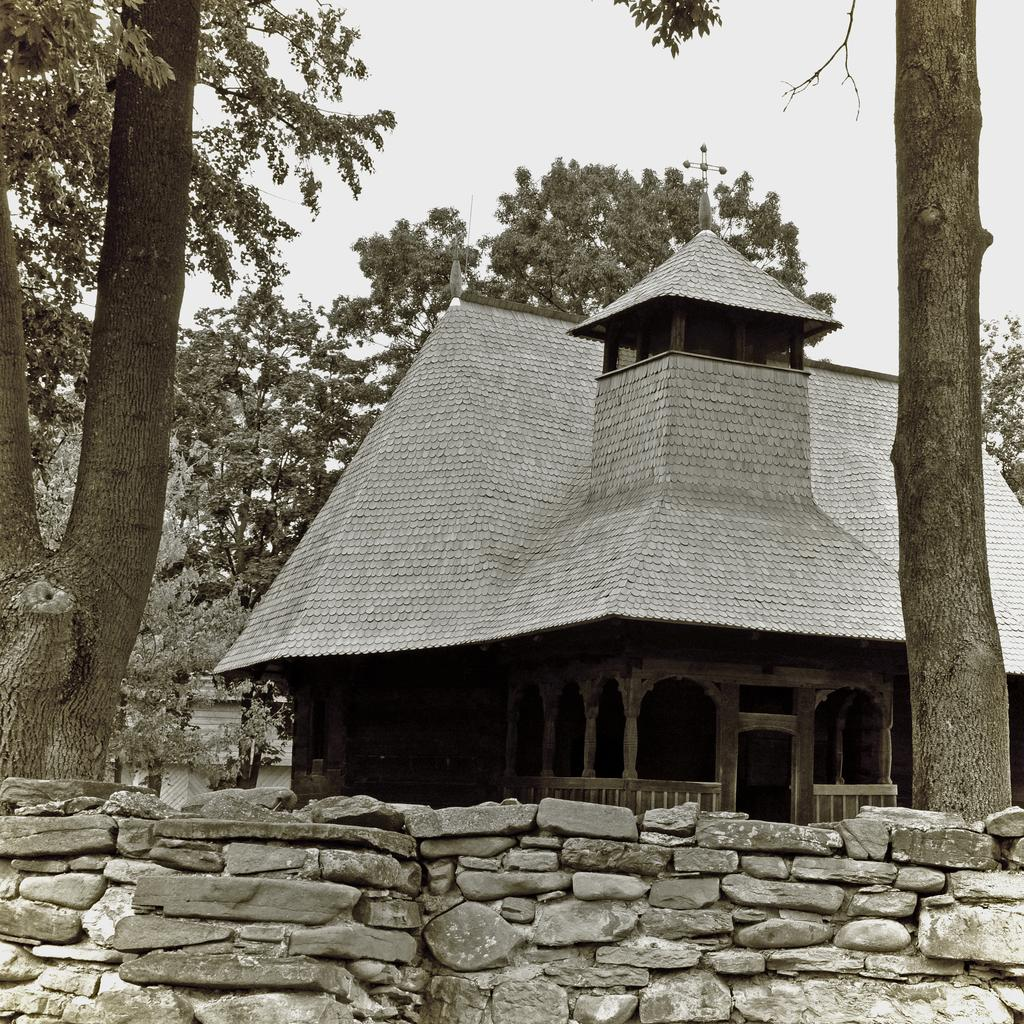What type of structure can be seen in the image? There is a stone fence in the image. What other structure is present in the image? There is a shed in the image. What can be seen in the background of the image? There are many trees in the background of the image. How many brothers are playing with the hose in the image? There are no brothers or hose present in the image. 